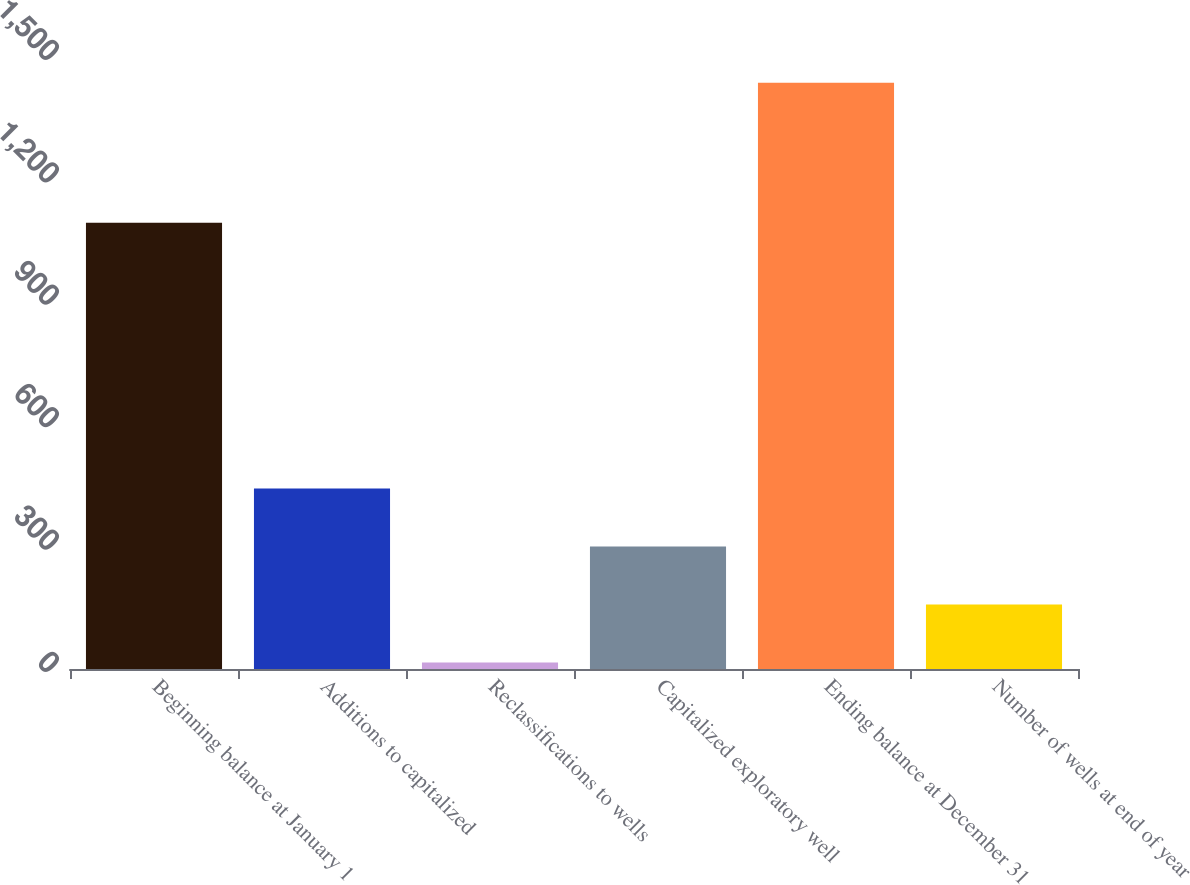Convert chart to OTSL. <chart><loc_0><loc_0><loc_500><loc_500><bar_chart><fcel>Beginning balance at January 1<fcel>Additions to capitalized<fcel>Reclassifications to wells<fcel>Capitalized exploratory well<fcel>Ending balance at December 31<fcel>Number of wells at end of year<nl><fcel>1094<fcel>442.3<fcel>16<fcel>300.2<fcel>1437<fcel>158.1<nl></chart> 